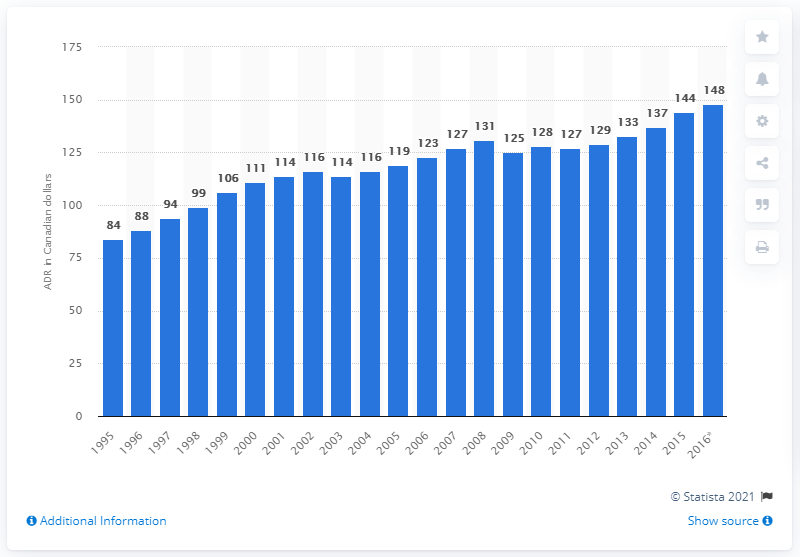Give some essential details in this illustration. In 2014, the average daily rate for a hotel room in Canada was 137 